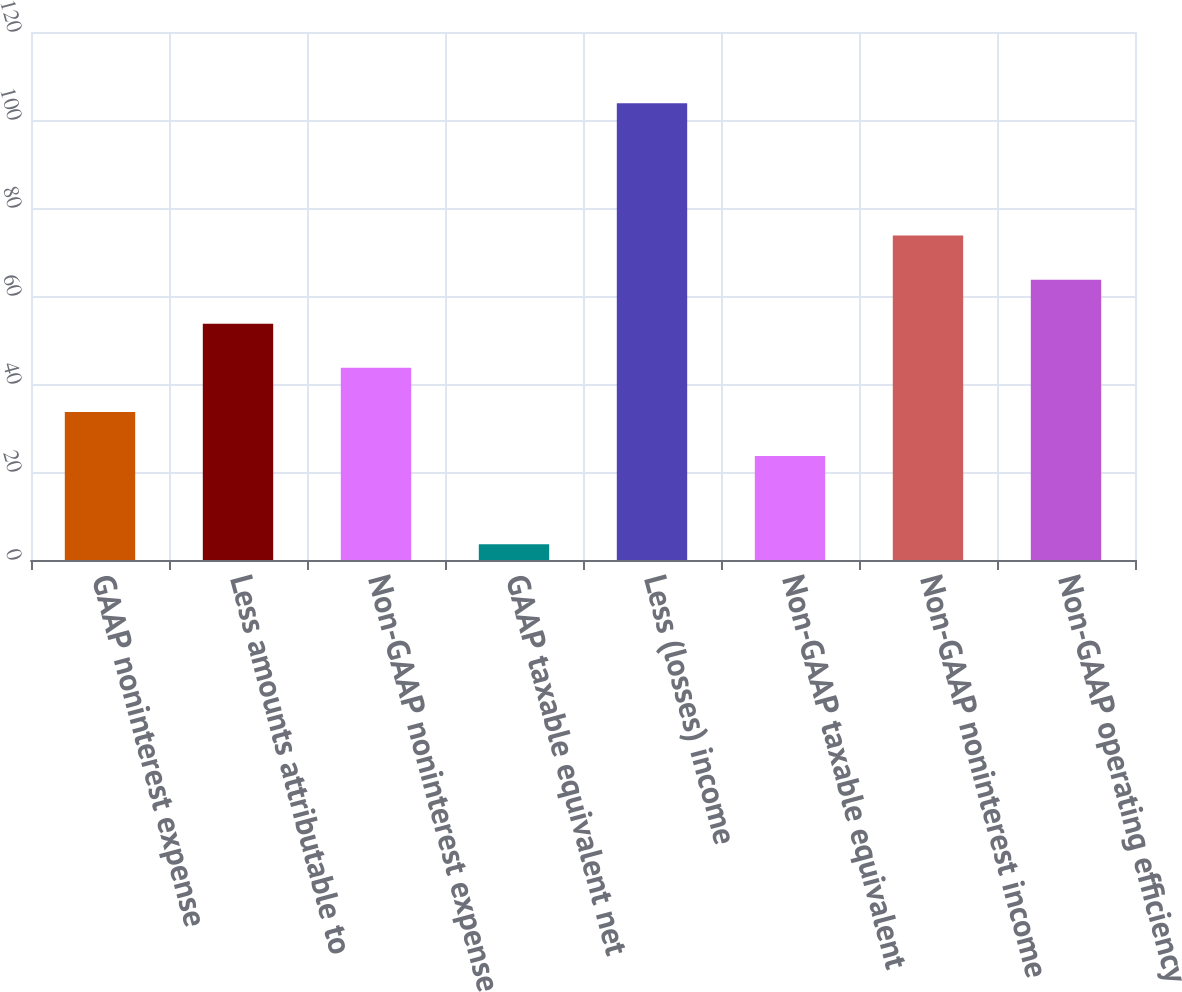<chart> <loc_0><loc_0><loc_500><loc_500><bar_chart><fcel>GAAP noninterest expense<fcel>Less amounts attributable to<fcel>Non-GAAP noninterest expense<fcel>GAAP taxable equivalent net<fcel>Less (losses) income<fcel>Non-GAAP taxable equivalent<fcel>Non-GAAP noninterest income<fcel>Non-GAAP operating efficiency<nl><fcel>33.66<fcel>53.7<fcel>43.68<fcel>3.6<fcel>103.8<fcel>23.64<fcel>73.74<fcel>63.72<nl></chart> 